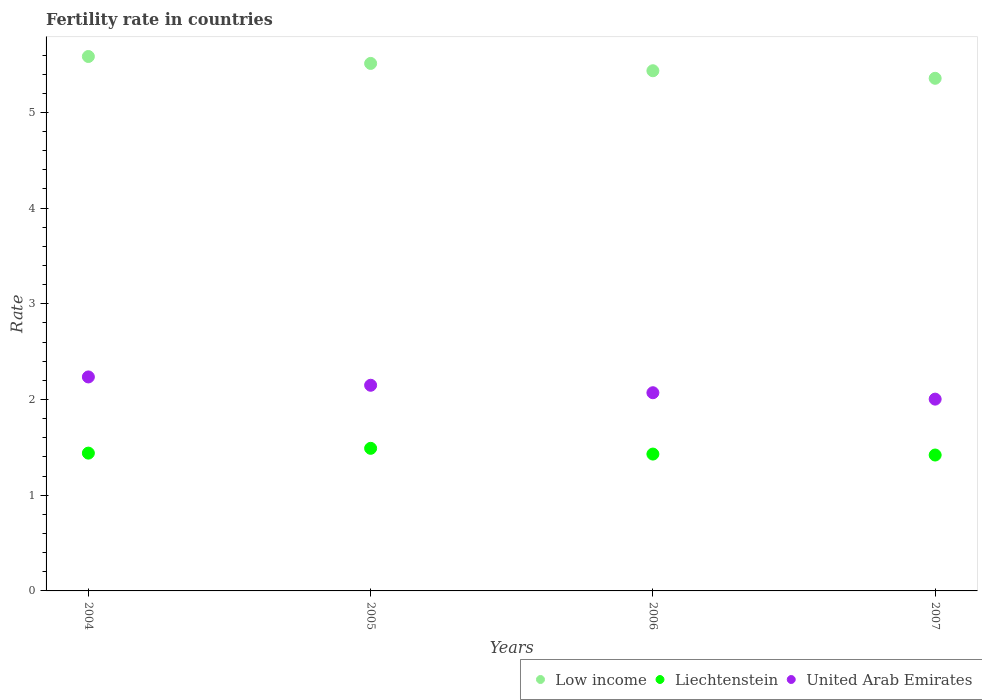What is the fertility rate in Low income in 2006?
Keep it short and to the point. 5.44. Across all years, what is the maximum fertility rate in Liechtenstein?
Give a very brief answer. 1.49. Across all years, what is the minimum fertility rate in United Arab Emirates?
Offer a very short reply. 2. In which year was the fertility rate in United Arab Emirates maximum?
Your response must be concise. 2004. What is the total fertility rate in Low income in the graph?
Offer a terse response. 21.89. What is the difference between the fertility rate in Liechtenstein in 2005 and that in 2006?
Ensure brevity in your answer.  0.06. What is the difference between the fertility rate in United Arab Emirates in 2006 and the fertility rate in Liechtenstein in 2004?
Provide a succinct answer. 0.63. What is the average fertility rate in Liechtenstein per year?
Your answer should be compact. 1.44. In the year 2007, what is the difference between the fertility rate in Liechtenstein and fertility rate in United Arab Emirates?
Your answer should be compact. -0.58. In how many years, is the fertility rate in United Arab Emirates greater than 5?
Your answer should be compact. 0. What is the ratio of the fertility rate in Liechtenstein in 2006 to that in 2007?
Provide a succinct answer. 1.01. What is the difference between the highest and the second highest fertility rate in United Arab Emirates?
Your answer should be very brief. 0.09. What is the difference between the highest and the lowest fertility rate in Liechtenstein?
Offer a very short reply. 0.07. Is the sum of the fertility rate in Liechtenstein in 2006 and 2007 greater than the maximum fertility rate in United Arab Emirates across all years?
Provide a succinct answer. Yes. Is it the case that in every year, the sum of the fertility rate in Low income and fertility rate in United Arab Emirates  is greater than the fertility rate in Liechtenstein?
Make the answer very short. Yes. Is the fertility rate in United Arab Emirates strictly less than the fertility rate in Low income over the years?
Your response must be concise. Yes. How many dotlines are there?
Offer a terse response. 3. How many years are there in the graph?
Provide a succinct answer. 4. What is the difference between two consecutive major ticks on the Y-axis?
Your answer should be compact. 1. Where does the legend appear in the graph?
Your answer should be very brief. Bottom right. How many legend labels are there?
Your answer should be compact. 3. What is the title of the graph?
Offer a terse response. Fertility rate in countries. Does "Turkey" appear as one of the legend labels in the graph?
Provide a short and direct response. No. What is the label or title of the X-axis?
Offer a very short reply. Years. What is the label or title of the Y-axis?
Make the answer very short. Rate. What is the Rate of Low income in 2004?
Ensure brevity in your answer.  5.58. What is the Rate in Liechtenstein in 2004?
Offer a terse response. 1.44. What is the Rate of United Arab Emirates in 2004?
Your answer should be very brief. 2.24. What is the Rate of Low income in 2005?
Provide a short and direct response. 5.51. What is the Rate of Liechtenstein in 2005?
Make the answer very short. 1.49. What is the Rate of United Arab Emirates in 2005?
Offer a terse response. 2.15. What is the Rate in Low income in 2006?
Provide a succinct answer. 5.44. What is the Rate in Liechtenstein in 2006?
Offer a terse response. 1.43. What is the Rate in United Arab Emirates in 2006?
Keep it short and to the point. 2.07. What is the Rate in Low income in 2007?
Give a very brief answer. 5.36. What is the Rate in Liechtenstein in 2007?
Offer a very short reply. 1.42. What is the Rate in United Arab Emirates in 2007?
Provide a succinct answer. 2. Across all years, what is the maximum Rate in Low income?
Make the answer very short. 5.58. Across all years, what is the maximum Rate of Liechtenstein?
Offer a very short reply. 1.49. Across all years, what is the maximum Rate in United Arab Emirates?
Your response must be concise. 2.24. Across all years, what is the minimum Rate in Low income?
Give a very brief answer. 5.36. Across all years, what is the minimum Rate in Liechtenstein?
Your answer should be compact. 1.42. Across all years, what is the minimum Rate of United Arab Emirates?
Provide a short and direct response. 2. What is the total Rate in Low income in the graph?
Give a very brief answer. 21.89. What is the total Rate in Liechtenstein in the graph?
Offer a very short reply. 5.78. What is the total Rate in United Arab Emirates in the graph?
Provide a succinct answer. 8.46. What is the difference between the Rate of Low income in 2004 and that in 2005?
Provide a succinct answer. 0.07. What is the difference between the Rate of Liechtenstein in 2004 and that in 2005?
Provide a short and direct response. -0.05. What is the difference between the Rate in United Arab Emirates in 2004 and that in 2005?
Offer a very short reply. 0.09. What is the difference between the Rate of Low income in 2004 and that in 2006?
Offer a terse response. 0.15. What is the difference between the Rate in United Arab Emirates in 2004 and that in 2006?
Keep it short and to the point. 0.17. What is the difference between the Rate in Low income in 2004 and that in 2007?
Your answer should be very brief. 0.23. What is the difference between the Rate of Liechtenstein in 2004 and that in 2007?
Offer a very short reply. 0.02. What is the difference between the Rate in United Arab Emirates in 2004 and that in 2007?
Keep it short and to the point. 0.23. What is the difference between the Rate in Low income in 2005 and that in 2006?
Provide a succinct answer. 0.08. What is the difference between the Rate in United Arab Emirates in 2005 and that in 2006?
Provide a short and direct response. 0.08. What is the difference between the Rate in Low income in 2005 and that in 2007?
Make the answer very short. 0.16. What is the difference between the Rate in Liechtenstein in 2005 and that in 2007?
Provide a short and direct response. 0.07. What is the difference between the Rate in United Arab Emirates in 2005 and that in 2007?
Give a very brief answer. 0.14. What is the difference between the Rate of Low income in 2006 and that in 2007?
Your answer should be very brief. 0.08. What is the difference between the Rate in United Arab Emirates in 2006 and that in 2007?
Provide a short and direct response. 0.07. What is the difference between the Rate in Low income in 2004 and the Rate in Liechtenstein in 2005?
Offer a very short reply. 4.09. What is the difference between the Rate in Low income in 2004 and the Rate in United Arab Emirates in 2005?
Your answer should be very brief. 3.44. What is the difference between the Rate of Liechtenstein in 2004 and the Rate of United Arab Emirates in 2005?
Make the answer very short. -0.71. What is the difference between the Rate of Low income in 2004 and the Rate of Liechtenstein in 2006?
Make the answer very short. 4.15. What is the difference between the Rate in Low income in 2004 and the Rate in United Arab Emirates in 2006?
Your response must be concise. 3.51. What is the difference between the Rate in Liechtenstein in 2004 and the Rate in United Arab Emirates in 2006?
Your answer should be very brief. -0.63. What is the difference between the Rate of Low income in 2004 and the Rate of Liechtenstein in 2007?
Offer a very short reply. 4.16. What is the difference between the Rate in Low income in 2004 and the Rate in United Arab Emirates in 2007?
Offer a terse response. 3.58. What is the difference between the Rate in Liechtenstein in 2004 and the Rate in United Arab Emirates in 2007?
Provide a short and direct response. -0.56. What is the difference between the Rate of Low income in 2005 and the Rate of Liechtenstein in 2006?
Ensure brevity in your answer.  4.08. What is the difference between the Rate in Low income in 2005 and the Rate in United Arab Emirates in 2006?
Provide a short and direct response. 3.44. What is the difference between the Rate of Liechtenstein in 2005 and the Rate of United Arab Emirates in 2006?
Your answer should be compact. -0.58. What is the difference between the Rate in Low income in 2005 and the Rate in Liechtenstein in 2007?
Make the answer very short. 4.09. What is the difference between the Rate of Low income in 2005 and the Rate of United Arab Emirates in 2007?
Give a very brief answer. 3.51. What is the difference between the Rate in Liechtenstein in 2005 and the Rate in United Arab Emirates in 2007?
Make the answer very short. -0.51. What is the difference between the Rate of Low income in 2006 and the Rate of Liechtenstein in 2007?
Keep it short and to the point. 4.02. What is the difference between the Rate in Low income in 2006 and the Rate in United Arab Emirates in 2007?
Offer a terse response. 3.43. What is the difference between the Rate in Liechtenstein in 2006 and the Rate in United Arab Emirates in 2007?
Your answer should be compact. -0.57. What is the average Rate of Low income per year?
Make the answer very short. 5.47. What is the average Rate of Liechtenstein per year?
Give a very brief answer. 1.45. What is the average Rate of United Arab Emirates per year?
Give a very brief answer. 2.12. In the year 2004, what is the difference between the Rate in Low income and Rate in Liechtenstein?
Provide a short and direct response. 4.14. In the year 2004, what is the difference between the Rate of Low income and Rate of United Arab Emirates?
Ensure brevity in your answer.  3.35. In the year 2004, what is the difference between the Rate of Liechtenstein and Rate of United Arab Emirates?
Your response must be concise. -0.8. In the year 2005, what is the difference between the Rate of Low income and Rate of Liechtenstein?
Provide a short and direct response. 4.02. In the year 2005, what is the difference between the Rate of Low income and Rate of United Arab Emirates?
Offer a terse response. 3.36. In the year 2005, what is the difference between the Rate of Liechtenstein and Rate of United Arab Emirates?
Your answer should be very brief. -0.66. In the year 2006, what is the difference between the Rate of Low income and Rate of Liechtenstein?
Your response must be concise. 4.01. In the year 2006, what is the difference between the Rate of Low income and Rate of United Arab Emirates?
Offer a very short reply. 3.36. In the year 2006, what is the difference between the Rate in Liechtenstein and Rate in United Arab Emirates?
Your response must be concise. -0.64. In the year 2007, what is the difference between the Rate of Low income and Rate of Liechtenstein?
Make the answer very short. 3.94. In the year 2007, what is the difference between the Rate in Low income and Rate in United Arab Emirates?
Provide a short and direct response. 3.35. In the year 2007, what is the difference between the Rate in Liechtenstein and Rate in United Arab Emirates?
Provide a succinct answer. -0.58. What is the ratio of the Rate in Low income in 2004 to that in 2005?
Your answer should be compact. 1.01. What is the ratio of the Rate of Liechtenstein in 2004 to that in 2005?
Give a very brief answer. 0.97. What is the ratio of the Rate of United Arab Emirates in 2004 to that in 2005?
Your answer should be compact. 1.04. What is the ratio of the Rate of Low income in 2004 to that in 2006?
Your response must be concise. 1.03. What is the ratio of the Rate of Liechtenstein in 2004 to that in 2006?
Your response must be concise. 1.01. What is the ratio of the Rate in United Arab Emirates in 2004 to that in 2006?
Keep it short and to the point. 1.08. What is the ratio of the Rate of Low income in 2004 to that in 2007?
Your answer should be compact. 1.04. What is the ratio of the Rate of Liechtenstein in 2004 to that in 2007?
Ensure brevity in your answer.  1.01. What is the ratio of the Rate of United Arab Emirates in 2004 to that in 2007?
Ensure brevity in your answer.  1.12. What is the ratio of the Rate in Low income in 2005 to that in 2006?
Your answer should be very brief. 1.01. What is the ratio of the Rate of Liechtenstein in 2005 to that in 2006?
Keep it short and to the point. 1.04. What is the ratio of the Rate of United Arab Emirates in 2005 to that in 2006?
Your answer should be very brief. 1.04. What is the ratio of the Rate in Liechtenstein in 2005 to that in 2007?
Provide a short and direct response. 1.05. What is the ratio of the Rate in United Arab Emirates in 2005 to that in 2007?
Ensure brevity in your answer.  1.07. What is the ratio of the Rate in Low income in 2006 to that in 2007?
Offer a terse response. 1.01. What is the ratio of the Rate of Liechtenstein in 2006 to that in 2007?
Offer a very short reply. 1.01. What is the ratio of the Rate in United Arab Emirates in 2006 to that in 2007?
Ensure brevity in your answer.  1.03. What is the difference between the highest and the second highest Rate of Low income?
Ensure brevity in your answer.  0.07. What is the difference between the highest and the second highest Rate in Liechtenstein?
Your answer should be compact. 0.05. What is the difference between the highest and the second highest Rate of United Arab Emirates?
Provide a short and direct response. 0.09. What is the difference between the highest and the lowest Rate of Low income?
Make the answer very short. 0.23. What is the difference between the highest and the lowest Rate of Liechtenstein?
Offer a very short reply. 0.07. What is the difference between the highest and the lowest Rate of United Arab Emirates?
Provide a short and direct response. 0.23. 